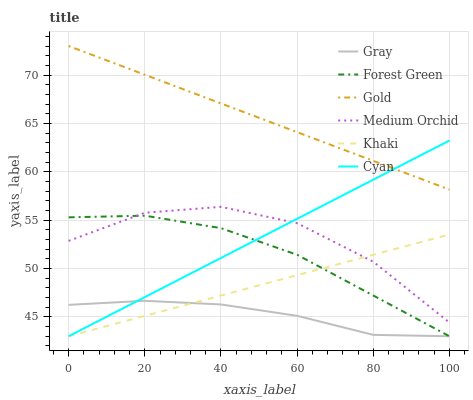Does Gray have the minimum area under the curve?
Answer yes or no. Yes. Does Gold have the maximum area under the curve?
Answer yes or no. Yes. Does Khaki have the minimum area under the curve?
Answer yes or no. No. Does Khaki have the maximum area under the curve?
Answer yes or no. No. Is Cyan the smoothest?
Answer yes or no. Yes. Is Medium Orchid the roughest?
Answer yes or no. Yes. Is Khaki the smoothest?
Answer yes or no. No. Is Khaki the roughest?
Answer yes or no. No. Does Gray have the lowest value?
Answer yes or no. Yes. Does Gold have the lowest value?
Answer yes or no. No. Does Gold have the highest value?
Answer yes or no. Yes. Does Khaki have the highest value?
Answer yes or no. No. Is Khaki less than Gold?
Answer yes or no. Yes. Is Gold greater than Forest Green?
Answer yes or no. Yes. Does Forest Green intersect Gray?
Answer yes or no. Yes. Is Forest Green less than Gray?
Answer yes or no. No. Is Forest Green greater than Gray?
Answer yes or no. No. Does Khaki intersect Gold?
Answer yes or no. No. 